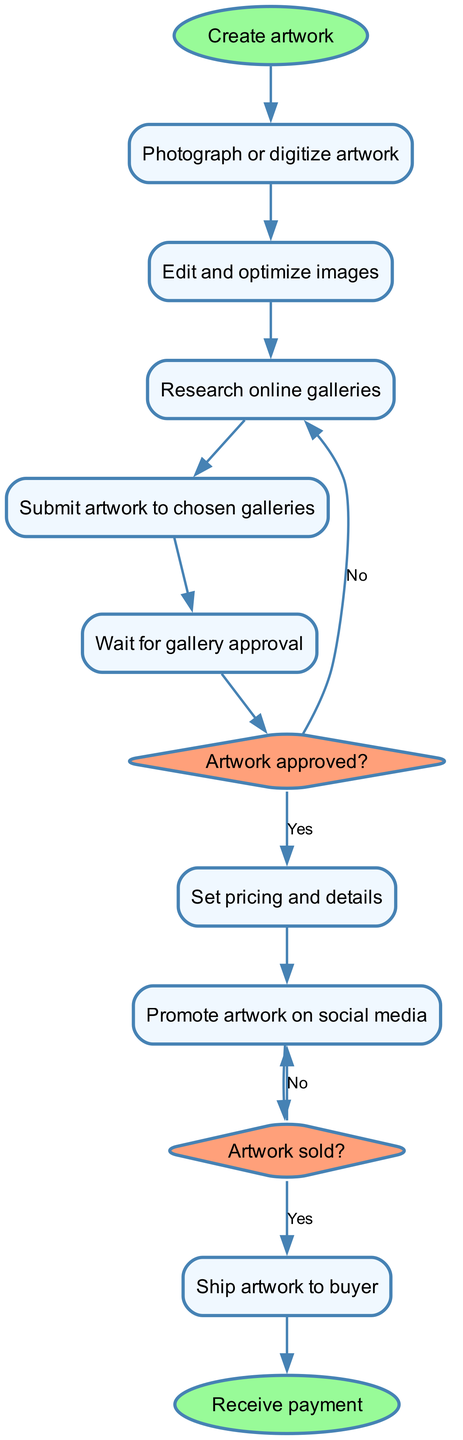What is the first step in the workflow? The first node in the diagram is "Create artwork", which indicates that the workflow begins with this action.
Answer: Create artwork How many nodes are in the diagram? By counting the individual elements listed as nodes in the provided data, there are twelve unique nodes shown within the diagram.
Answer: Twelve What does the node labeled "approved" indicate? The "approved" node is a decision point that questions whether the artwork has been approved by the gallery, which leads to two possible outcomes.
Answer: Artwork approved? What is the follow-up action after artwork is submitted? After submitting the artwork, the next step in the workflow is to "Wait for gallery approval", showing a sequential progression in the process.
Answer: Wait for gallery approval What happens if the artwork is not approved? If the "approved" decision is "No", the workflow indicates that the next action redirects back to "Research online galleries", suggesting further exploration is necessary.
Answer: Research online galleries What is the final outcome of this workflow? The last step in the diagram concludes with "Receive payment", indicating that the process finishes once the transaction for the artwork is completed.
Answer: Receive payment How many edges connect the "sale" and "ship" nodes? There is one directed edge that exits from the "sale" node to the "ship" node, indicating a direct sequential relationship if the artwork is sold.
Answer: One What action follows immediately after setting pricing? After the "Set pricing and details" node, the workflow moves to "Promote artwork on social media", showing the necessary promotional steps after pricing.
Answer: Promote artwork on social media What type of node is “approved”? The "approved" node is represented as a diamond shape in the diagram, which typically indicates a decision point in flowcharts.
Answer: Diamond 